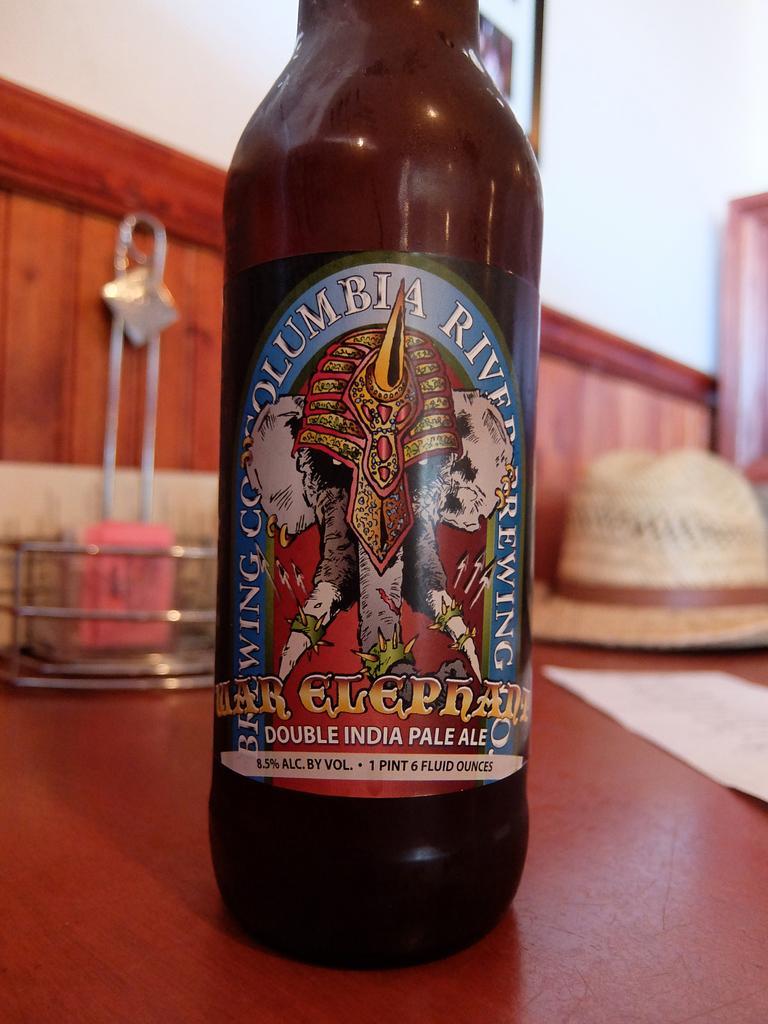Can you describe this image briefly? In this image I can see a bottle. 